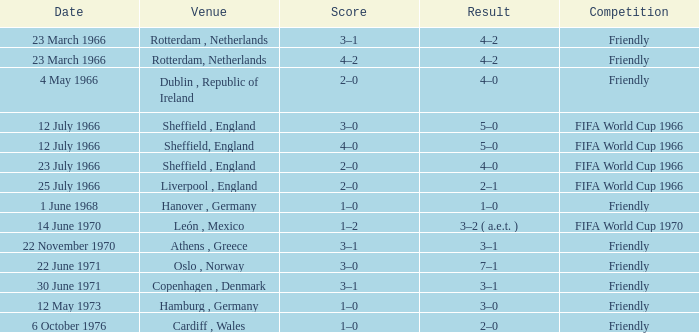In which occurrence's setting was rotterdam, netherlands? 4–2, 4–2. 